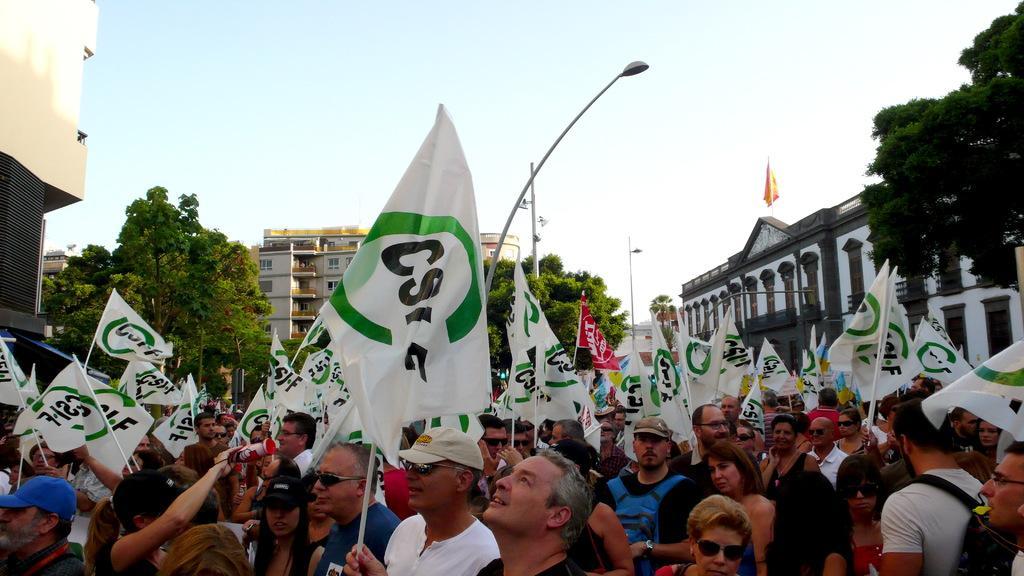Please provide a concise description of this image. In this picture we can see a group of people, here we can see flags and in the background we can see buildings, trees, electric poles, sky. 